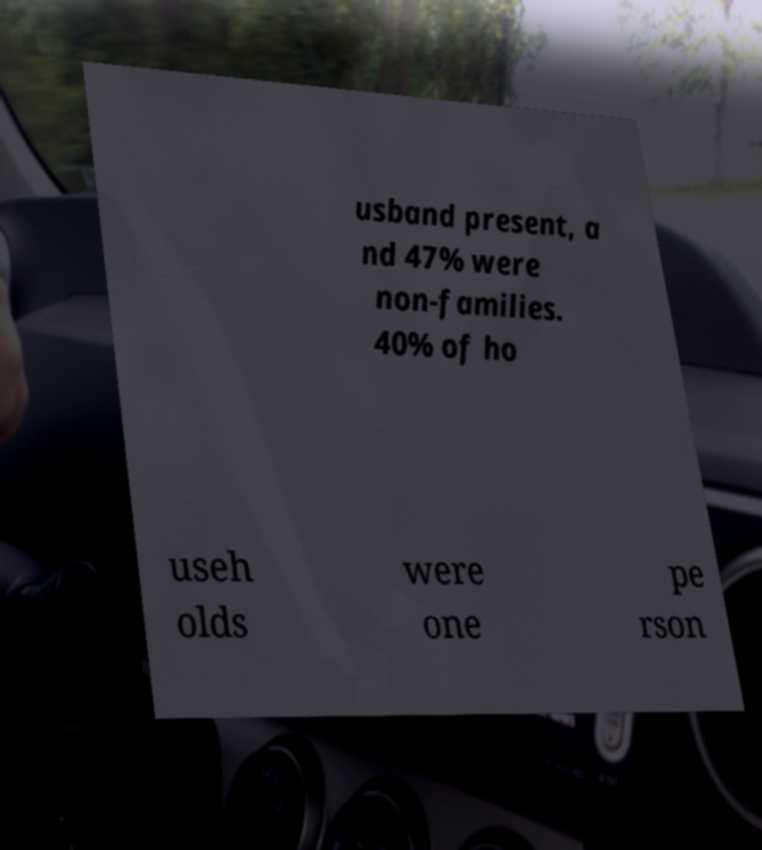Please read and relay the text visible in this image. What does it say? usband present, a nd 47% were non-families. 40% of ho useh olds were one pe rson 